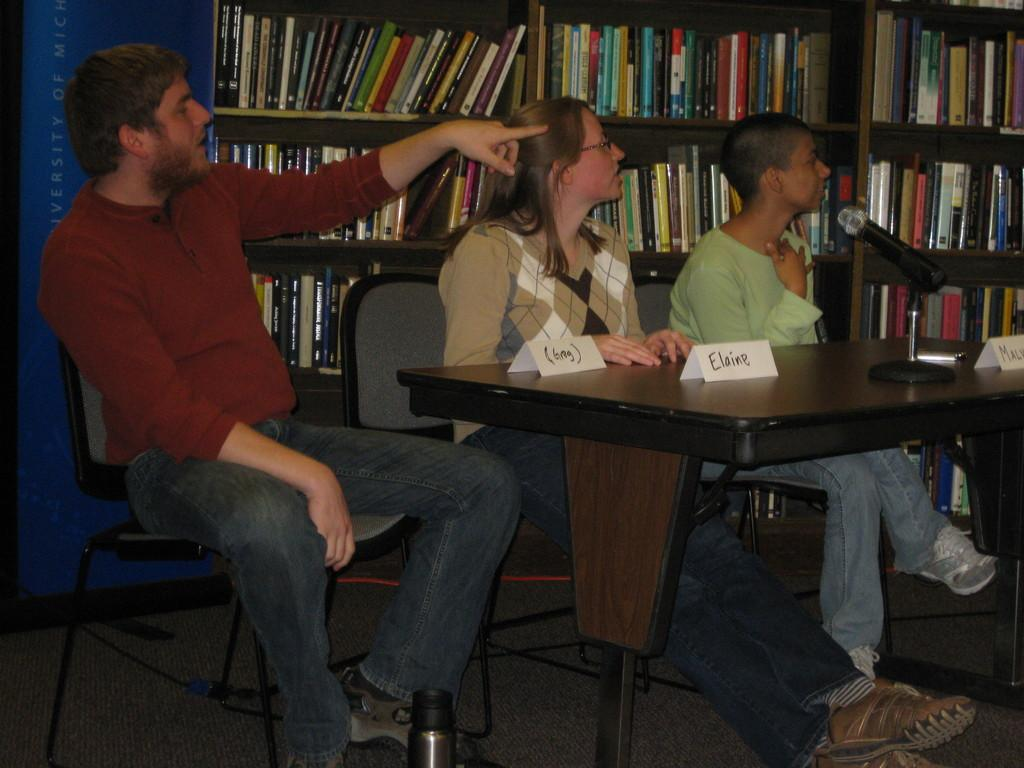How many people are sitting in the image? There are three persons sitting on chairs in the image. What is in front of the chairs? There is a table in front of the chairs. What object is on the table? A microphone (mic) is present on the table. What else can be seen on the table? Name boards are on the table. What can be seen in the background of the image? There are cupboards with books in the background. What is visible behind the table and chairs? There is a wall visible in the image. What type of toothpaste is being used by the person on the left in the image? There is no toothpaste present in the image; it features three persons sitting on chairs with a table, microphone, and name boards. How many letters are being passed between the persons in the image? There are no letters visible in the image; the focus is on the persons sitting on chairs, the table, microphone, and name boards. 